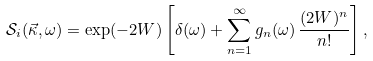Convert formula to latex. <formula><loc_0><loc_0><loc_500><loc_500>\mathcal { S } _ { i } ( \vec { \kappa } , \omega ) = \exp ( - 2 W ) \left [ \delta ( \omega ) + \sum _ { n = 1 } ^ { \infty } g _ { n } ( \omega ) \, \frac { ( 2 W ) ^ { n } } { n ! } \right ] ,</formula> 